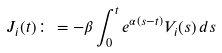Convert formula to latex. <formula><loc_0><loc_0><loc_500><loc_500>J _ { i } ( t ) \colon = - \beta \int _ { 0 } ^ { t } e ^ { \alpha ( s - t ) } V _ { i } ( s ) \, d s</formula> 